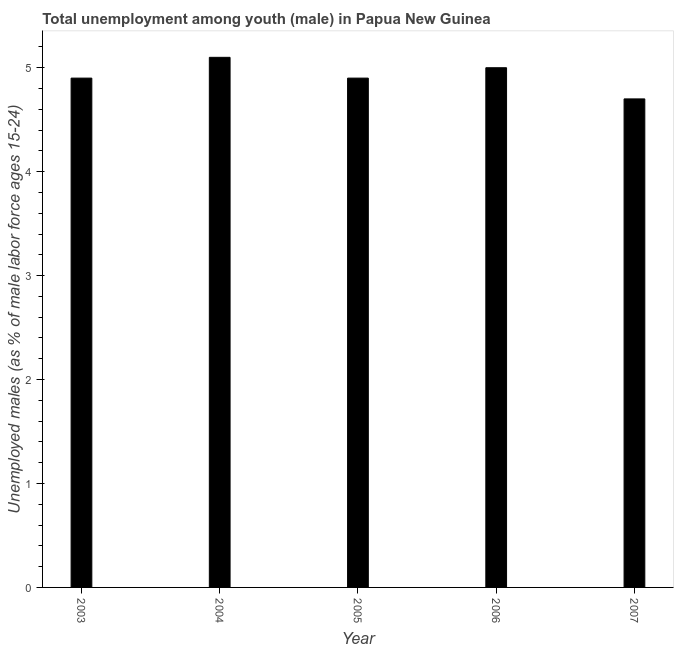Does the graph contain any zero values?
Provide a succinct answer. No. What is the title of the graph?
Offer a terse response. Total unemployment among youth (male) in Papua New Guinea. What is the label or title of the Y-axis?
Make the answer very short. Unemployed males (as % of male labor force ages 15-24). What is the unemployed male youth population in 2003?
Offer a terse response. 4.9. Across all years, what is the maximum unemployed male youth population?
Keep it short and to the point. 5.1. Across all years, what is the minimum unemployed male youth population?
Make the answer very short. 4.7. In which year was the unemployed male youth population maximum?
Provide a short and direct response. 2004. What is the sum of the unemployed male youth population?
Give a very brief answer. 24.6. What is the difference between the unemployed male youth population in 2005 and 2006?
Give a very brief answer. -0.1. What is the average unemployed male youth population per year?
Give a very brief answer. 4.92. What is the median unemployed male youth population?
Ensure brevity in your answer.  4.9. Do a majority of the years between 2007 and 2005 (inclusive) have unemployed male youth population greater than 4.2 %?
Your answer should be compact. Yes. What is the ratio of the unemployed male youth population in 2003 to that in 2005?
Your answer should be compact. 1. What is the difference between the highest and the lowest unemployed male youth population?
Your answer should be very brief. 0.4. Are all the bars in the graph horizontal?
Give a very brief answer. No. What is the Unemployed males (as % of male labor force ages 15-24) in 2003?
Your answer should be compact. 4.9. What is the Unemployed males (as % of male labor force ages 15-24) in 2004?
Your answer should be compact. 5.1. What is the Unemployed males (as % of male labor force ages 15-24) of 2005?
Your response must be concise. 4.9. What is the Unemployed males (as % of male labor force ages 15-24) in 2006?
Give a very brief answer. 5. What is the Unemployed males (as % of male labor force ages 15-24) in 2007?
Your response must be concise. 4.7. What is the difference between the Unemployed males (as % of male labor force ages 15-24) in 2003 and 2006?
Give a very brief answer. -0.1. What is the difference between the Unemployed males (as % of male labor force ages 15-24) in 2004 and 2005?
Make the answer very short. 0.2. What is the difference between the Unemployed males (as % of male labor force ages 15-24) in 2004 and 2006?
Your response must be concise. 0.1. What is the difference between the Unemployed males (as % of male labor force ages 15-24) in 2006 and 2007?
Provide a short and direct response. 0.3. What is the ratio of the Unemployed males (as % of male labor force ages 15-24) in 2003 to that in 2004?
Make the answer very short. 0.96. What is the ratio of the Unemployed males (as % of male labor force ages 15-24) in 2003 to that in 2005?
Provide a short and direct response. 1. What is the ratio of the Unemployed males (as % of male labor force ages 15-24) in 2003 to that in 2007?
Make the answer very short. 1.04. What is the ratio of the Unemployed males (as % of male labor force ages 15-24) in 2004 to that in 2005?
Your answer should be compact. 1.04. What is the ratio of the Unemployed males (as % of male labor force ages 15-24) in 2004 to that in 2007?
Offer a terse response. 1.08. What is the ratio of the Unemployed males (as % of male labor force ages 15-24) in 2005 to that in 2007?
Offer a very short reply. 1.04. What is the ratio of the Unemployed males (as % of male labor force ages 15-24) in 2006 to that in 2007?
Provide a succinct answer. 1.06. 